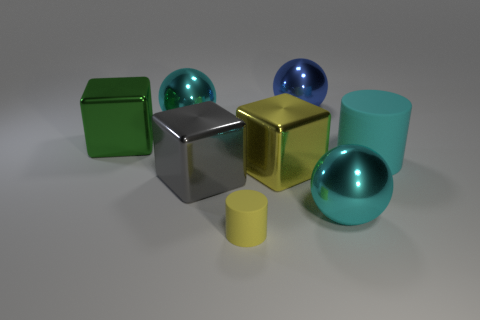Add 2 tiny green cylinders. How many objects exist? 10 Subtract all large gray blocks. How many blocks are left? 2 Subtract all balls. How many objects are left? 5 Subtract 2 cubes. How many cubes are left? 1 Subtract all gray spheres. How many brown cylinders are left? 0 Subtract all small yellow objects. Subtract all blue shiny balls. How many objects are left? 6 Add 3 tiny yellow cylinders. How many tiny yellow cylinders are left? 4 Add 4 yellow objects. How many yellow objects exist? 6 Subtract all gray cubes. How many cubes are left? 2 Subtract 0 cyan cubes. How many objects are left? 8 